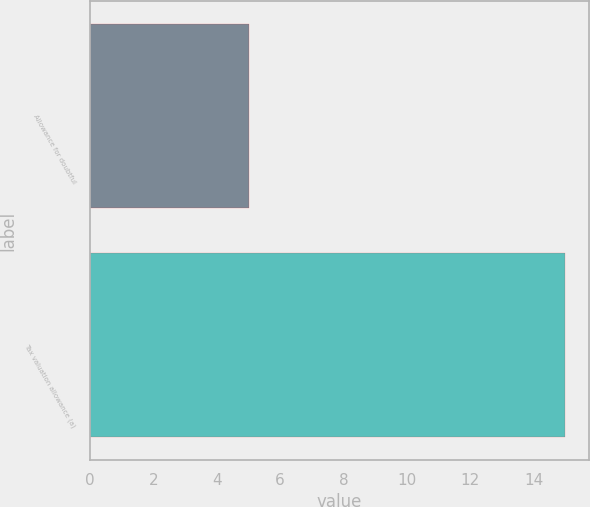Convert chart to OTSL. <chart><loc_0><loc_0><loc_500><loc_500><bar_chart><fcel>Allowance for doubtful<fcel>Tax valuation allowance (a)<nl><fcel>5<fcel>15<nl></chart> 